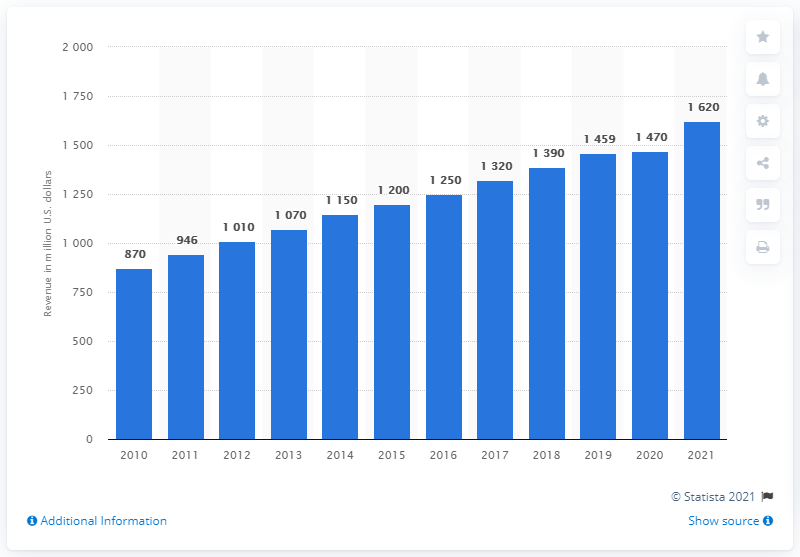List a handful of essential elements in this visual. According to estimates, sponsorship spending on the NFL reached approximately $16.2 billion in the 2021 season. In the year 2012, Nike began providing uniforms and apparel to all 32 NFL teams. 